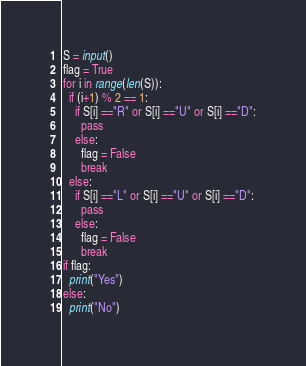<code> <loc_0><loc_0><loc_500><loc_500><_Python_>S = input()
flag = True
for i in range(len(S)):
  if (i+1) % 2 == 1:
    if S[i] =="R" or S[i] =="U" or S[i] =="D":
      pass
    else:
      flag = False
      break
  else:
    if S[i] =="L" or S[i] =="U" or S[i] =="D":
      pass
    else:
      flag = False
      break
if flag:
  print("Yes")
else:
  print("No")</code> 